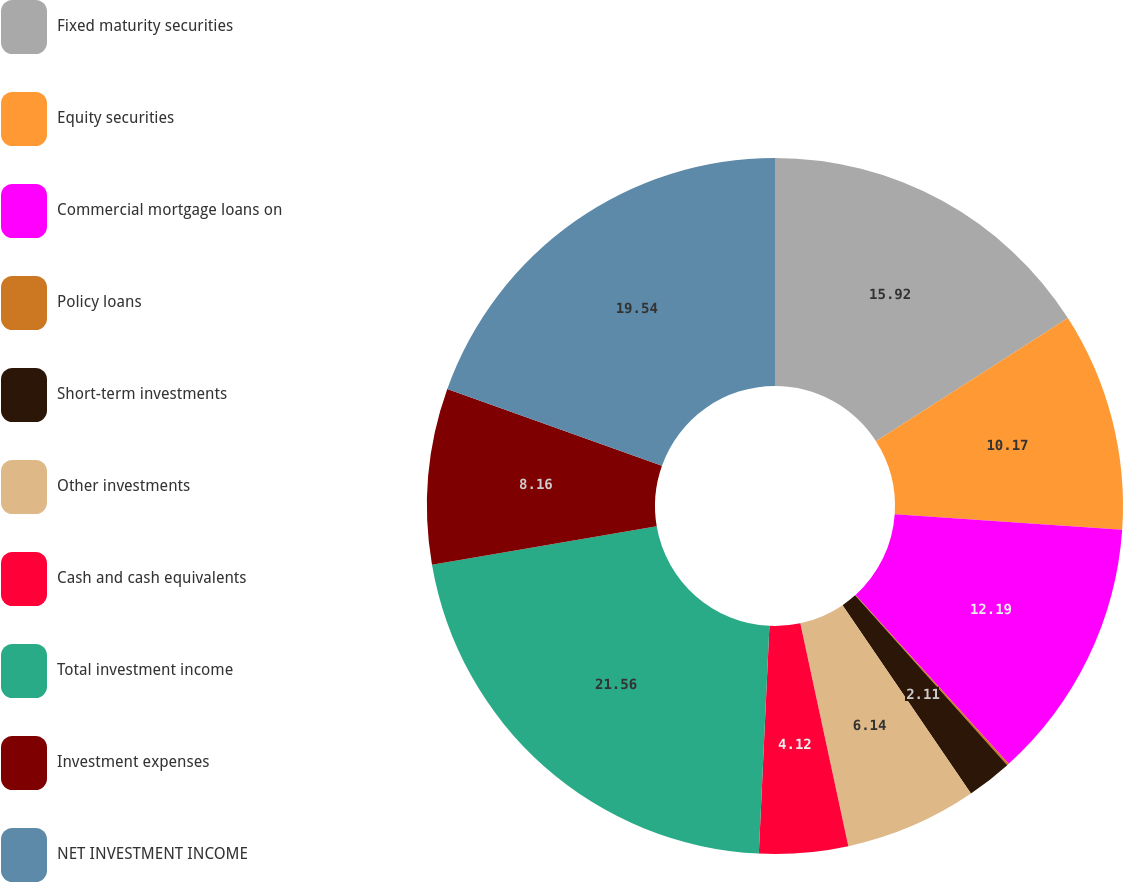Convert chart. <chart><loc_0><loc_0><loc_500><loc_500><pie_chart><fcel>Fixed maturity securities<fcel>Equity securities<fcel>Commercial mortgage loans on<fcel>Policy loans<fcel>Short-term investments<fcel>Other investments<fcel>Cash and cash equivalents<fcel>Total investment income<fcel>Investment expenses<fcel>NET INVESTMENT INCOME<nl><fcel>15.92%<fcel>10.17%<fcel>12.19%<fcel>0.09%<fcel>2.11%<fcel>6.14%<fcel>4.12%<fcel>21.56%<fcel>8.16%<fcel>19.54%<nl></chart> 